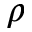Convert formula to latex. <formula><loc_0><loc_0><loc_500><loc_500>\rho</formula> 